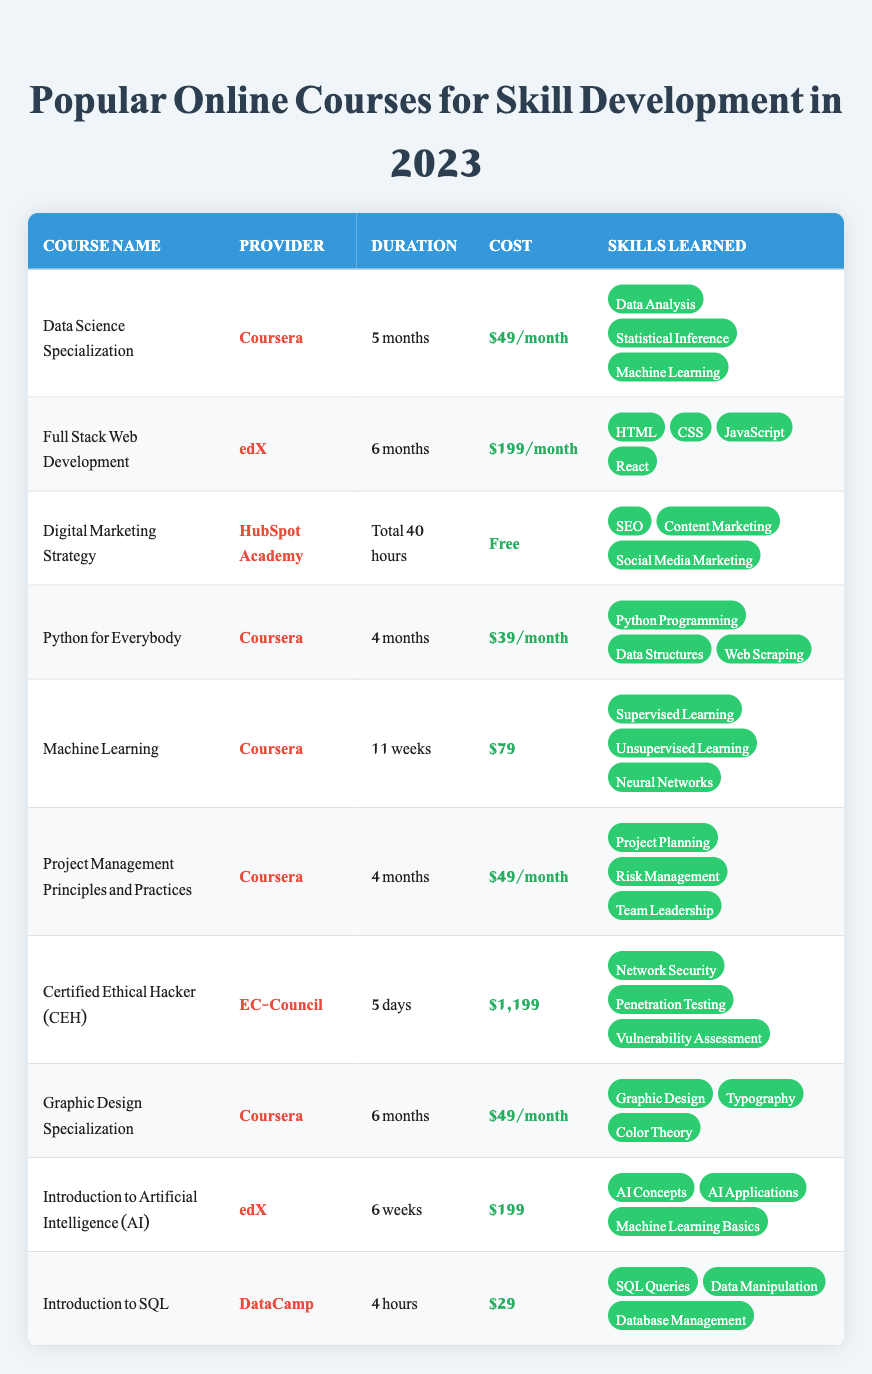What is the cost of the "Certified Ethical Hacker (CEH)" course? The cost of the "Certified Ethical Hacker (CEH)" course is clearly indicated in the table as "$1,199".
Answer: $1,199 Which course has the shortest duration? By comparing the duration of all courses, "Certified Ethical Hacker (CEH)" is 5 days, which is the shortest duration listed.
Answer: Certified Ethical Hacker (CEH) Are there any free courses available in this table? The "Digital Marketing Strategy" course is labeled as "Free" in the cost column, confirming that there is at least one free course offered.
Answer: Yes What skills are learned in the "Graphic Design Specialization" course? The table lists three skills for the "Graphic Design Specialization": "Graphic Design," "Typography," and "Color Theory," which are mentioned in the skills learned column.
Answer: Graphic Design, Typography, Color Theory How much does the "Full Stack Web Development" course cost in total if a student completes the course over its full duration? The "Full Stack Web Development" course costs $199 per month and lasts 6 months. Thus, the total cost is calculated by multiplying the monthly cost by the duration: 199 * 6 = $1,194.
Answer: $1,194 What is the average cost of the courses offered by Coursera? There are four Coursera courses: "Data Science Specialization" ($49/month for 5 months), "Python for Everybody" ($39/month for 4 months), "Machine Learning" ($79), and "Project Management Principles and Practices" ($49/month for 4 months). The monthly equivalents for the first three (49*5 = 245, 39*4 = 156, 79 = 79) and the last one (49*4 = 196) sum to 676 and divide by the number of courses (4) gives an average of 169.
Answer: $169 Does the "Introduction to SQL" course teach anything related to web scraping? The skills learned in the "Introduction to SQL" course are "SQL Queries," "Data Manipulation," and "Database Management." Since "Web Scraping" is not listed among these skills, it confirms that this course does not cover that topic.
Answer: No Which course provides skills related to "Machine Learning"? Both "Machine Learning" and "Data Science Specialization" courses provide skills including "Machine Learning", "Supervised Learning" and "Unsupervised Learning" respectively. This information can be derived from the skills learned section of each course.
Answer: Machine Learning, Data Science Specialization What is the total duration of the "Digital Marketing Strategy" course in hours? The "Digital Marketing Strategy" course states that its duration is "Total 40 hours." Therefore, the total duration is simply 40 hours, as provided in the table.
Answer: 40 hours 